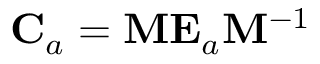<formula> <loc_0><loc_0><loc_500><loc_500>{ { C } _ { a } } = { M } { { E } _ { a } } { { M } ^ { - 1 } }</formula> 